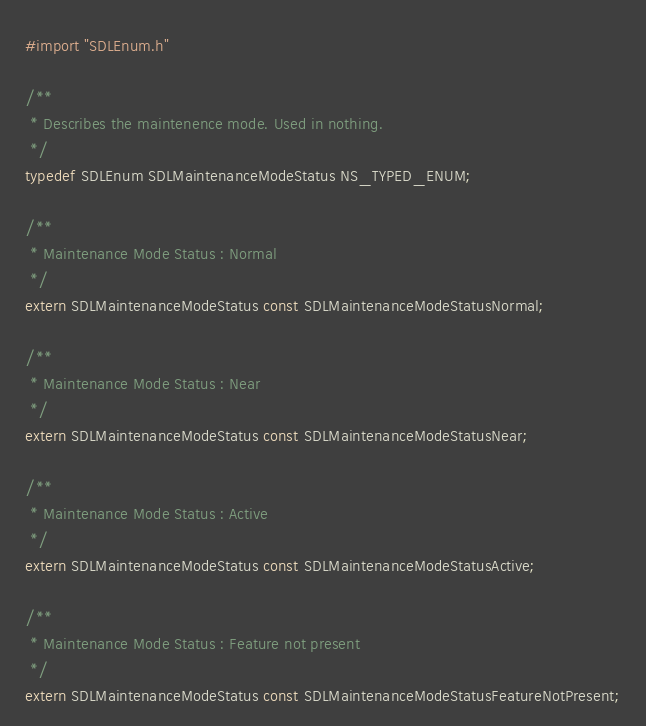Convert code to text. <code><loc_0><loc_0><loc_500><loc_500><_C_>
#import "SDLEnum.h"

/**
 * Describes the maintenence mode. Used in nothing.
 */
typedef SDLEnum SDLMaintenanceModeStatus NS_TYPED_ENUM;

/**
 * Maintenance Mode Status : Normal
 */
extern SDLMaintenanceModeStatus const SDLMaintenanceModeStatusNormal;

/**
 * Maintenance Mode Status : Near
 */
extern SDLMaintenanceModeStatus const SDLMaintenanceModeStatusNear;

/**
 * Maintenance Mode Status : Active
 */
extern SDLMaintenanceModeStatus const SDLMaintenanceModeStatusActive;

/**
 * Maintenance Mode Status : Feature not present
 */
extern SDLMaintenanceModeStatus const SDLMaintenanceModeStatusFeatureNotPresent;
</code> 